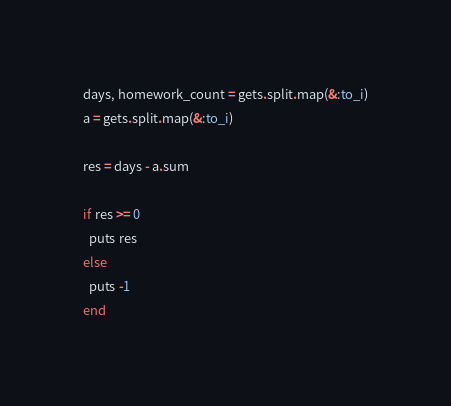Convert code to text. <code><loc_0><loc_0><loc_500><loc_500><_Ruby_>days, homework_count = gets.split.map(&:to_i)
a = gets.split.map(&:to_i)

res = days - a.sum

if res >= 0
  puts res
else
  puts -1
end</code> 